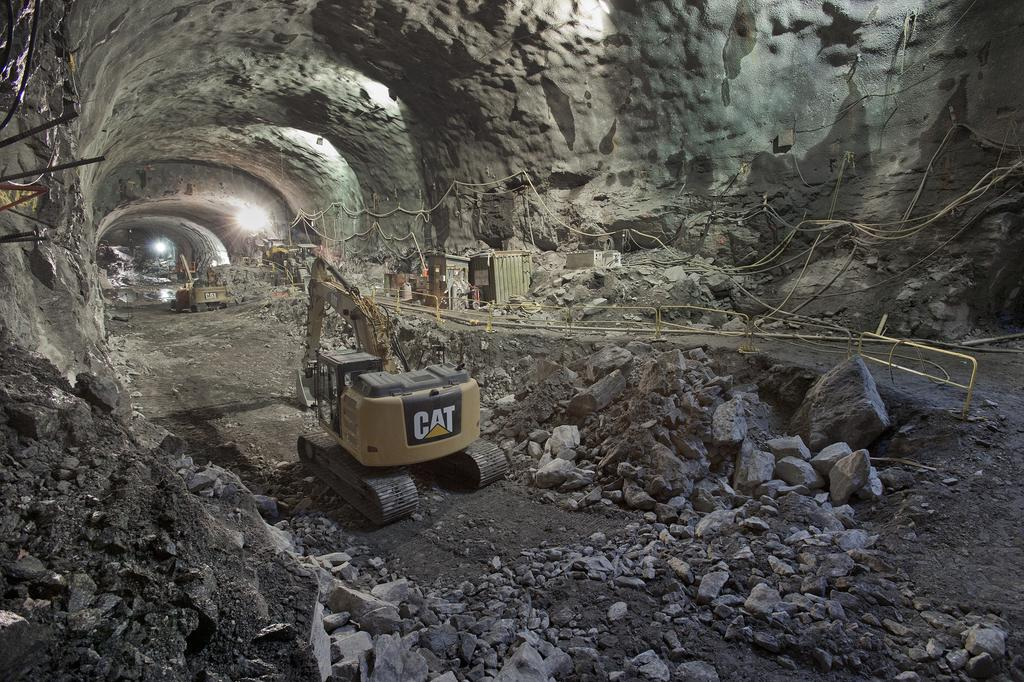What type of structure can be seen in the image? There is a tunnel in the image. What can be seen illuminating the tunnel? There are lights in the image. What might be used for safety purposes in the tunnel? Railings are present in the image. What might be used for securing or tying objects in the image? Ropes are visible in the image. What type of machinery is present in the image? Excavators are in the image. What type of natural materials are present in the image? Rocks and stones are visible in the image. What type of ground material is present in the image? Soil is in the image. Can you describe any unspecified objects in the image? There are a few unspecified objects in the image. What type of fruit can be seen hanging from the railings in the image? There is no fruit, including apples or yams, hanging from the railings in the image. 